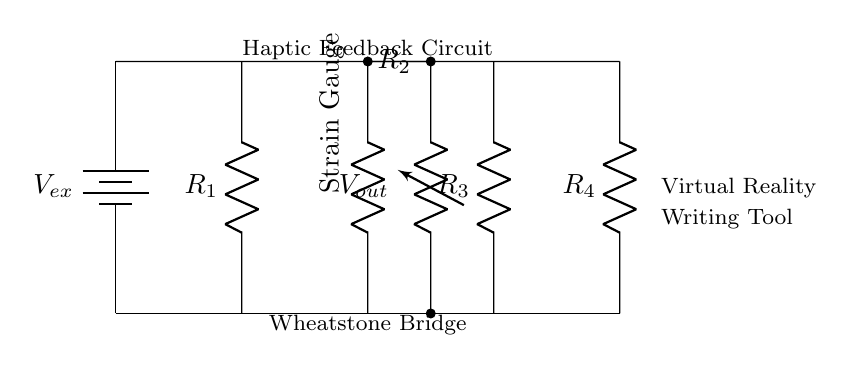What type of circuit is this? The circuit is a Wheatstone Bridge, characterized by its configuration that is commonly used for measuring resistance changes. The description indicated on the diagram confirms this type.
Answer: Wheatstone Bridge What is the role of the strain gauge in this circuit? The strain gauge acts as one of the resistors in the bridge and is used to measure strain, which alters its resistance based on physical movement. This change in resistance is essential for detecting minute movements.
Answer: Measure strain What is the purpose of the voltage source labeled Vex? The voltage source Vex provides the necessary power to the circuit, enabling the operation of the Wheatstone Bridge by supplying a potential difference across the resistors.
Answer: Power supply How many resistors are present in the circuit? There are four resistors present in the circuit, specifically R1, R2 (the strain gauge), R3, and R4, as indicated in the diagram.
Answer: Four What will happen to Vout if R2 (the strain gauge) experiences an increase in resistance? If R2 increases in resistance, it will create an imbalance in the bridge, leading to a change in the output voltage Vout, thereby indicating a physical change or movement.
Answer: Vout will change What is indicated by the labels "Haptic Feedback Circuit" and "Virtual Reality Writing Tool"? These labels suggest that the circuit is designed for a specific application: to provide haptic feedback in virtual reality environments, particularly for writing tools, indicating that changes in resistance will enhance the writing experience.
Answer: Application context Which component directly measures the output voltage? The component that measures the output voltage is the voltage resistor labeled Vout, which connects between the outputs of the Wheatstone Bridge to read the voltage difference caused by changes in resistance.
Answer: Vout 